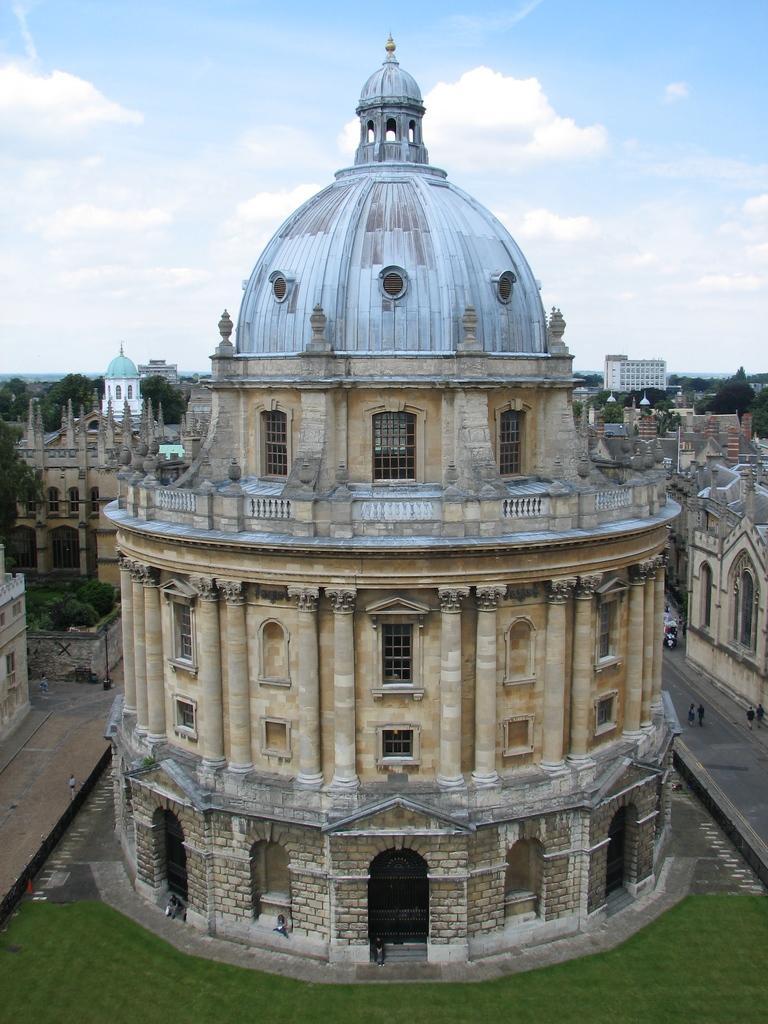In one or two sentences, can you explain what this image depicts? In this image I can see few buildings, trees in green color and the sky is in blue and white color. 